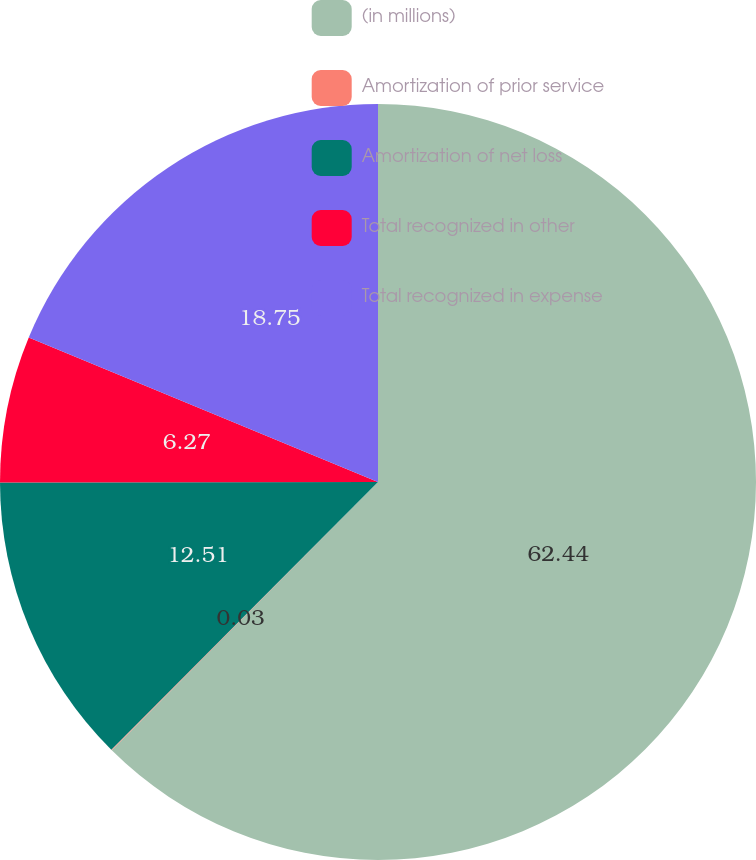Convert chart to OTSL. <chart><loc_0><loc_0><loc_500><loc_500><pie_chart><fcel>(in millions)<fcel>Amortization of prior service<fcel>Amortization of net loss<fcel>Total recognized in other<fcel>Total recognized in expense<nl><fcel>62.43%<fcel>0.03%<fcel>12.51%<fcel>6.27%<fcel>18.75%<nl></chart> 